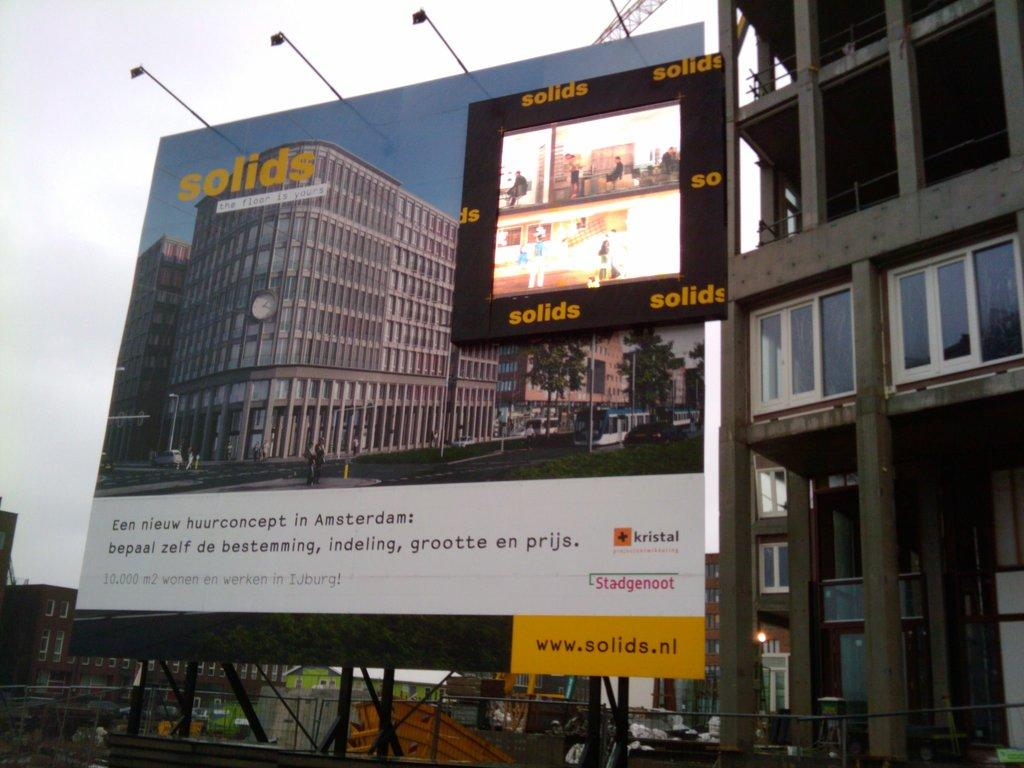Provide a one-sentence caption for the provided image. lighted billboard for solids and shows their website www.solids.nl. 